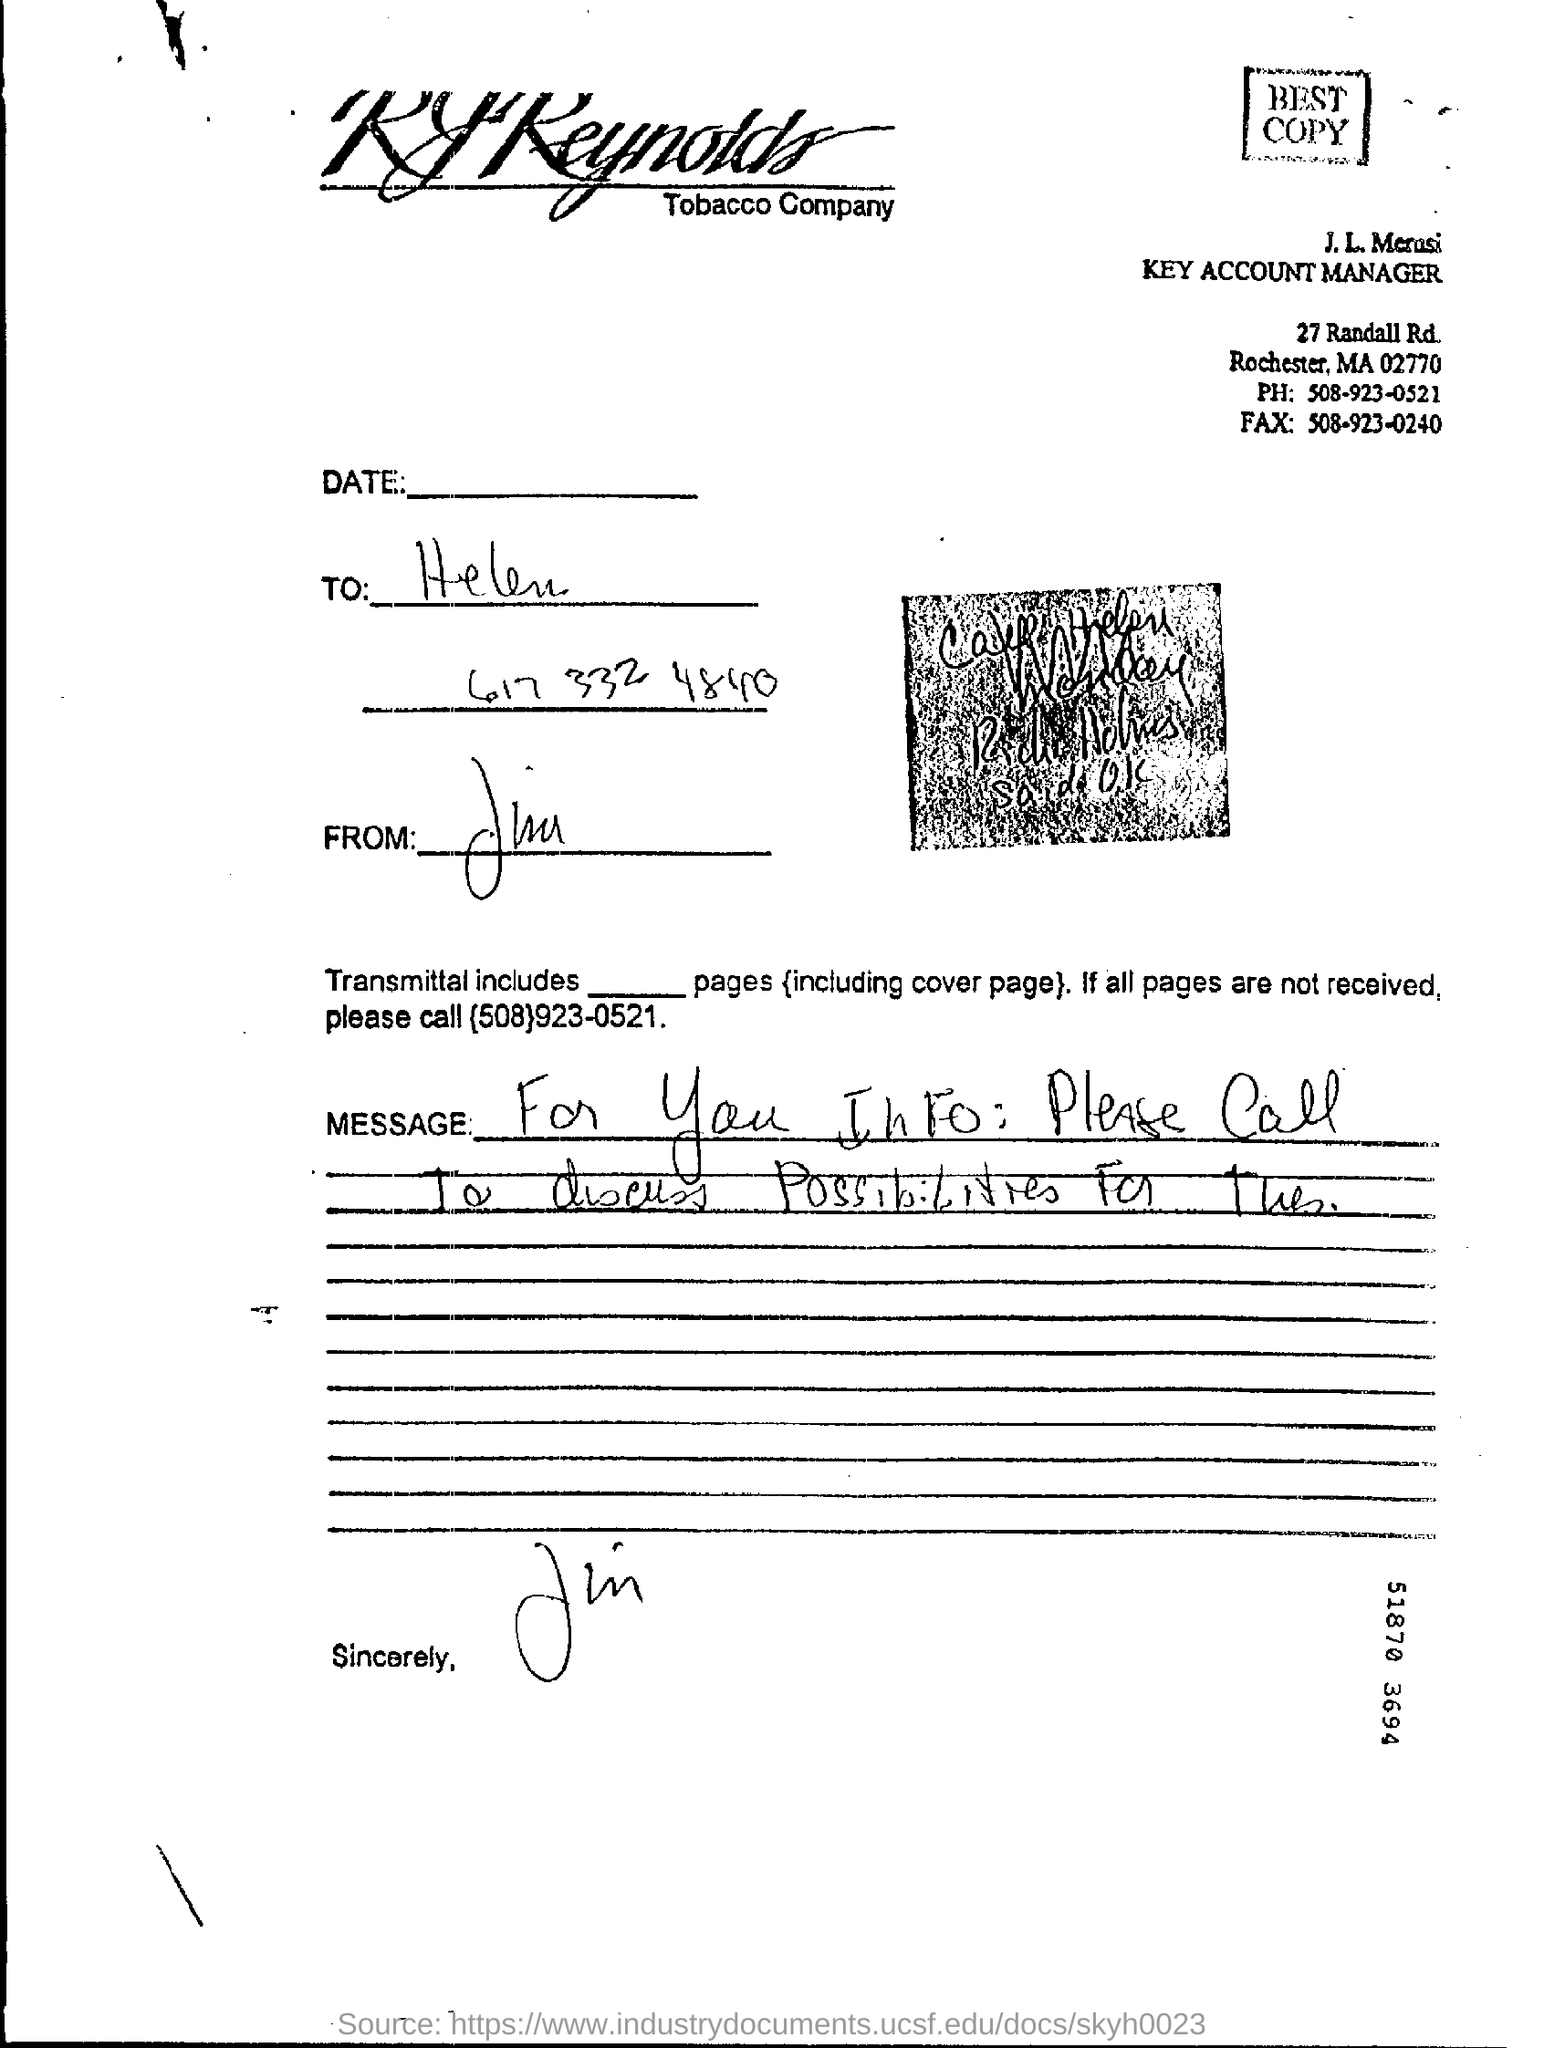Outline some significant characteristics in this image. The fax number mentioned in the letter is 508-923-0240. The phone number mentioned in the letter is 508-923-0521. 